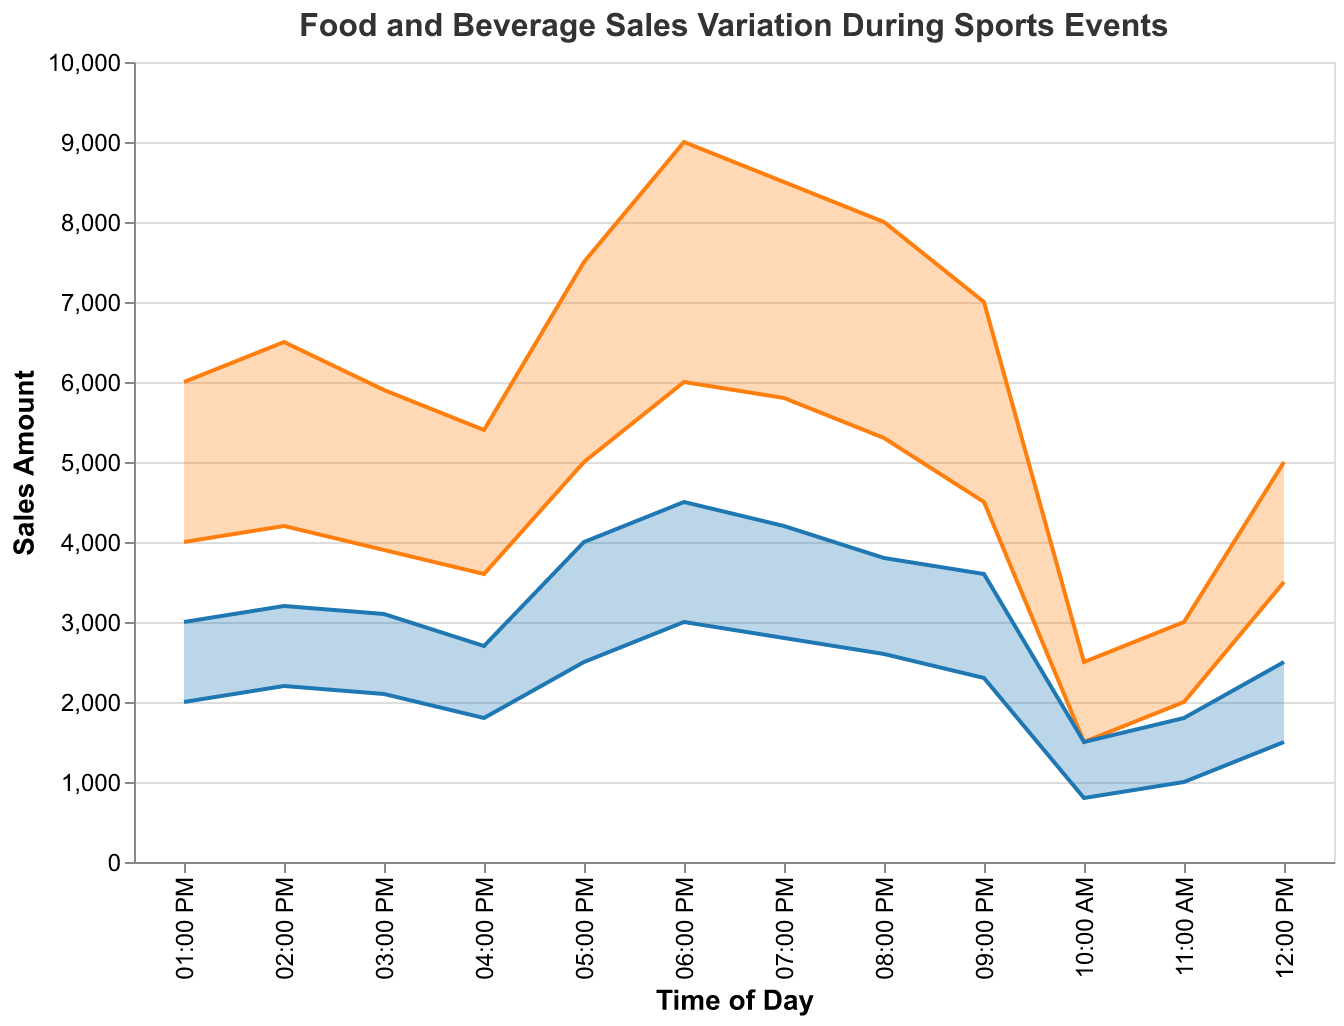What's the title of the figure? The title of the figure is usually located at the top of the chart. For this chart, the title reads "Food and Beverage Sales Variation During Sports Events."
Answer: Food and Beverage Sales Variation During Sports Events How does the food sales amount vary between 12:00 PM and 02:00 PM? From the plot, at 12:00 PM, food sales vary between 3,500 and 5,000. At 01:00 PM, they vary between 4,000 and 6,000. At 02:00 PM, the range is between 4,200 and 6,500.
Answer: Sales amount increases within this time range Which time of day has the highest maximum beverage sales? We need to look at the highest point on the BeverageMax line. From the figure, the highest value for BeverageMax occurs at 06:00 PM, reaching 4,500.
Answer: 06:00 PM How does the food sales range compare to the beverage sales range at 05:00 PM? At 05:00 PM, food sales range from 5,000 to 7,500, whereas beverage sales range from 2,500 to 4,000. By subtracting the minimum values from the maximum values, we can determine that the food sales range (7,500-5,000=2,500) is broader than the beverage sales range (4,000-2,500=1,500).
Answer: Food sales range is broader What happens to the beverage sales range after 07:00 PM? Observing the beverage sales range at 07:00 PM and times after, we can see that it begins to decline. From 07:00 PM (2,800 to 4,200), 08:00 PM (2,600 to 3,800), and 09:00 PM (2,300 to 3,600), the trend shows a decreasing pattern.
Answer: It declines What's the average maximum sales of food from 10:00 AM to 04:00 PM? The maximum sales values are: 2,500, 3,000, 5,000, 6,000, 6,500, 5,900, and 5,400. Summing them up equals 34,300, and dividing by 7 time slots, we get 4,900 (34,300/7).
Answer: 4,900 Compare the food sales range at 10:00 AM to the food sales range at 09:00 PM. At 10:00 AM, the food sales range is from 1,500 to 2,500, a range of 1,000. At 09:00 PM, the food sales range is from 4,500 to 7,000, a range of 2,500. The food sales range at 09:00 PM is significantly larger than at 10:00 AM.
Answer: The range at 09:00 PM is larger During which time slot is the difference between the maximum and minimum beverage sales the smallest? Subtracting BeverageMin from BeverageMax for each time slot: 10:00 AM (1,500-800=700), 11:00 AM (1,800-1,000=800), 12:00 PM (2,500-1,500=1,000), 01:00 PM (3,000-2,000=1,000), 02:00 PM (3,200-2,200=1,000), 03:00 PM (3,100-2,100=1,000), 04:00 PM (2,700-1,800=900), 05:00 PM (4,000-2,500=1,500), 06:00 PM (4,500-3,000=1,500), 07:00 PM (4,200-2,800=1,400), 08:00 PM (3,800-2,600=1,200), and 09:00 PM (3,600-2,300=1,300). The smallest difference is 700 at 10:00 AM.
Answer: 10:00 AM 